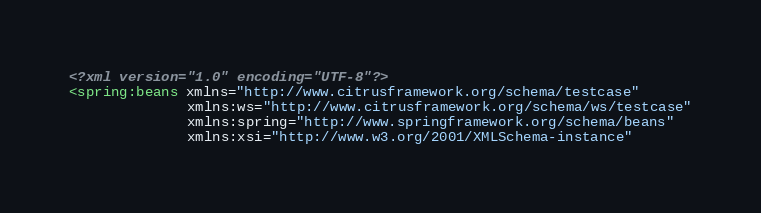Convert code to text. <code><loc_0><loc_0><loc_500><loc_500><_XML_><?xml version="1.0" encoding="UTF-8"?>
<spring:beans xmlns="http://www.citrusframework.org/schema/testcase" 
              xmlns:ws="http://www.citrusframework.org/schema/ws/testcase"
              xmlns:spring="http://www.springframework.org/schema/beans" 
              xmlns:xsi="http://www.w3.org/2001/XMLSchema-instance" </code> 